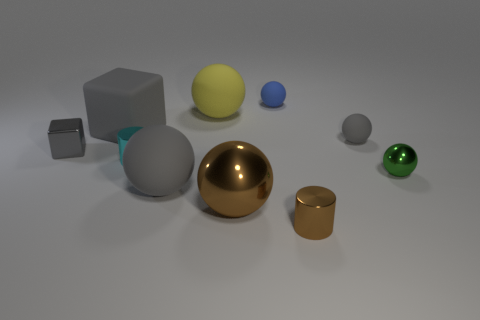Are there any tiny red matte cylinders?
Ensure brevity in your answer.  No. There is a big gray object behind the small green object; what is its material?
Offer a very short reply. Rubber. There is a large sphere that is the same color as the metallic cube; what is it made of?
Ensure brevity in your answer.  Rubber. What number of big objects are cyan metal cylinders or metallic cylinders?
Give a very brief answer. 0. The big metallic object is what color?
Your response must be concise. Brown. Is there a gray object that is to the left of the cylinder in front of the brown metallic sphere?
Offer a very short reply. Yes. Is the number of gray things that are in front of the green shiny thing less than the number of tiny green things?
Give a very brief answer. No. Are the cylinder that is right of the large brown ball and the big brown sphere made of the same material?
Ensure brevity in your answer.  Yes. What is the color of the big object that is the same material as the tiny cyan thing?
Your answer should be very brief. Brown. Are there fewer gray things in front of the yellow matte object than brown balls that are on the left side of the gray matte block?
Ensure brevity in your answer.  No. 